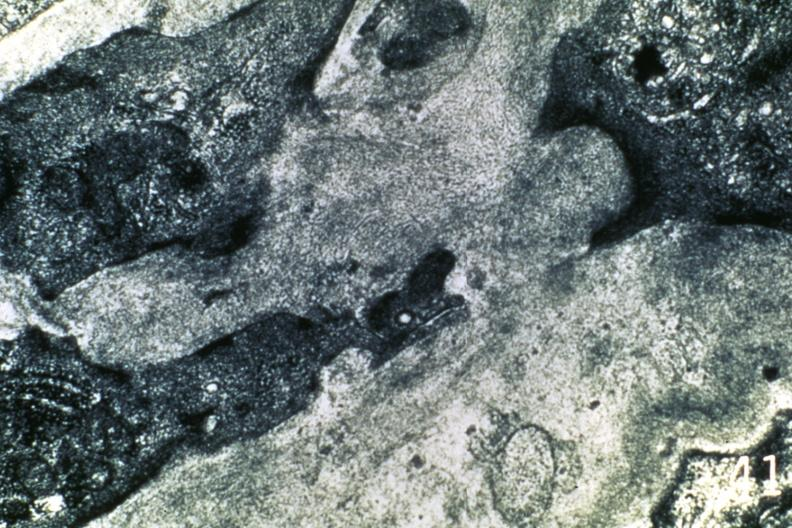what is present?
Answer the question using a single word or phrase. Amyloidosis 